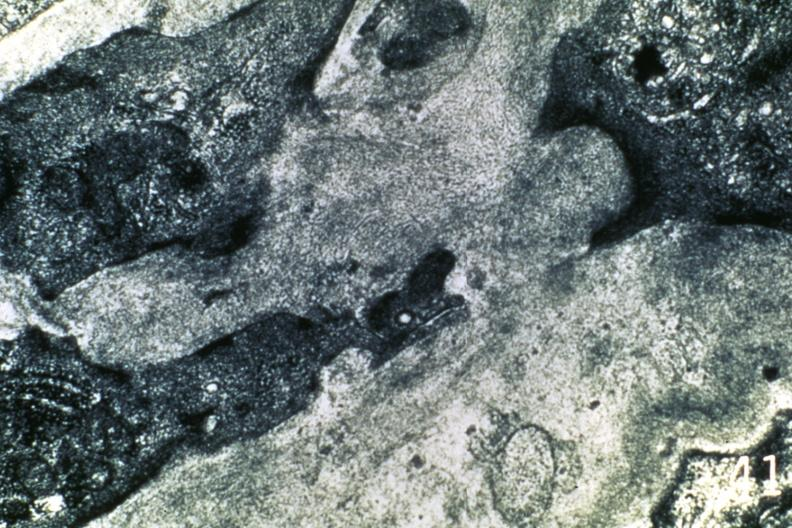what is present?
Answer the question using a single word or phrase. Amyloidosis 